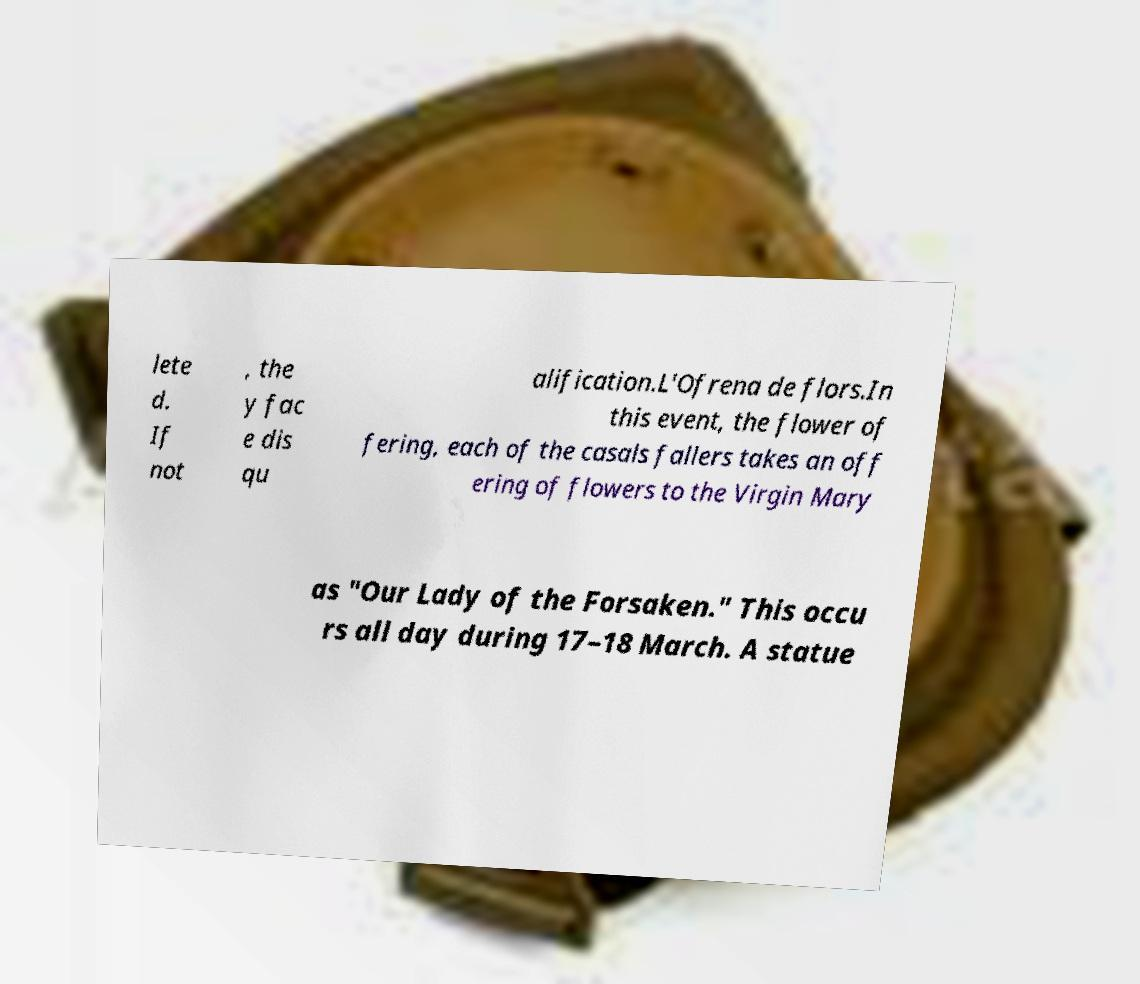I need the written content from this picture converted into text. Can you do that? lete d. If not , the y fac e dis qu alification.L'Ofrena de flors.In this event, the flower of fering, each of the casals fallers takes an off ering of flowers to the Virgin Mary as "Our Lady of the Forsaken." This occu rs all day during 17–18 March. A statue 